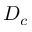Convert formula to latex. <formula><loc_0><loc_0><loc_500><loc_500>D _ { c }</formula> 